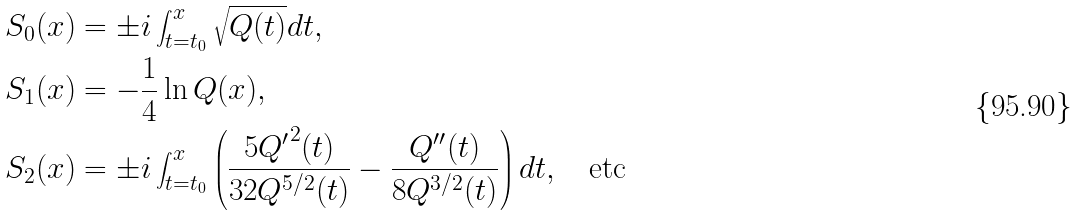Convert formula to latex. <formula><loc_0><loc_0><loc_500><loc_500>S _ { 0 } ( x ) & = \pm i \int _ { t = t _ { 0 } } ^ { x } \sqrt { Q ( t ) } d t , \\ S _ { 1 } ( x ) & = - \frac { 1 } { 4 } \ln Q ( x ) , \\ S _ { 2 } ( x ) & = \pm i \int _ { t = t _ { 0 } } ^ { x } \left ( \frac { 5 { Q ^ { \prime } } ^ { 2 } ( t ) } { 3 2 Q ^ { 5 / 2 } ( t ) } - \frac { Q ^ { \prime \prime } ( t ) } { 8 Q ^ { 3 / 2 } ( t ) } \right ) d t , \quad \text {etc}</formula> 